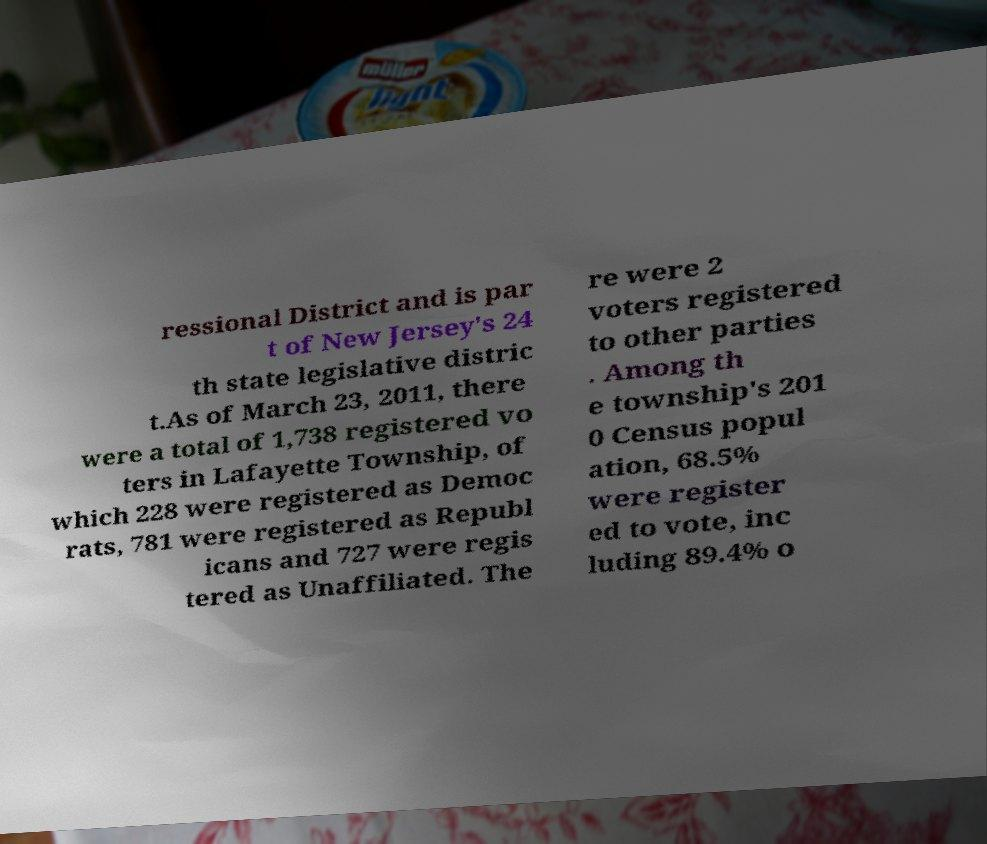For documentation purposes, I need the text within this image transcribed. Could you provide that? ressional District and is par t of New Jersey's 24 th state legislative distric t.As of March 23, 2011, there were a total of 1,738 registered vo ters in Lafayette Township, of which 228 were registered as Democ rats, 781 were registered as Republ icans and 727 were regis tered as Unaffiliated. The re were 2 voters registered to other parties . Among th e township's 201 0 Census popul ation, 68.5% were register ed to vote, inc luding 89.4% o 